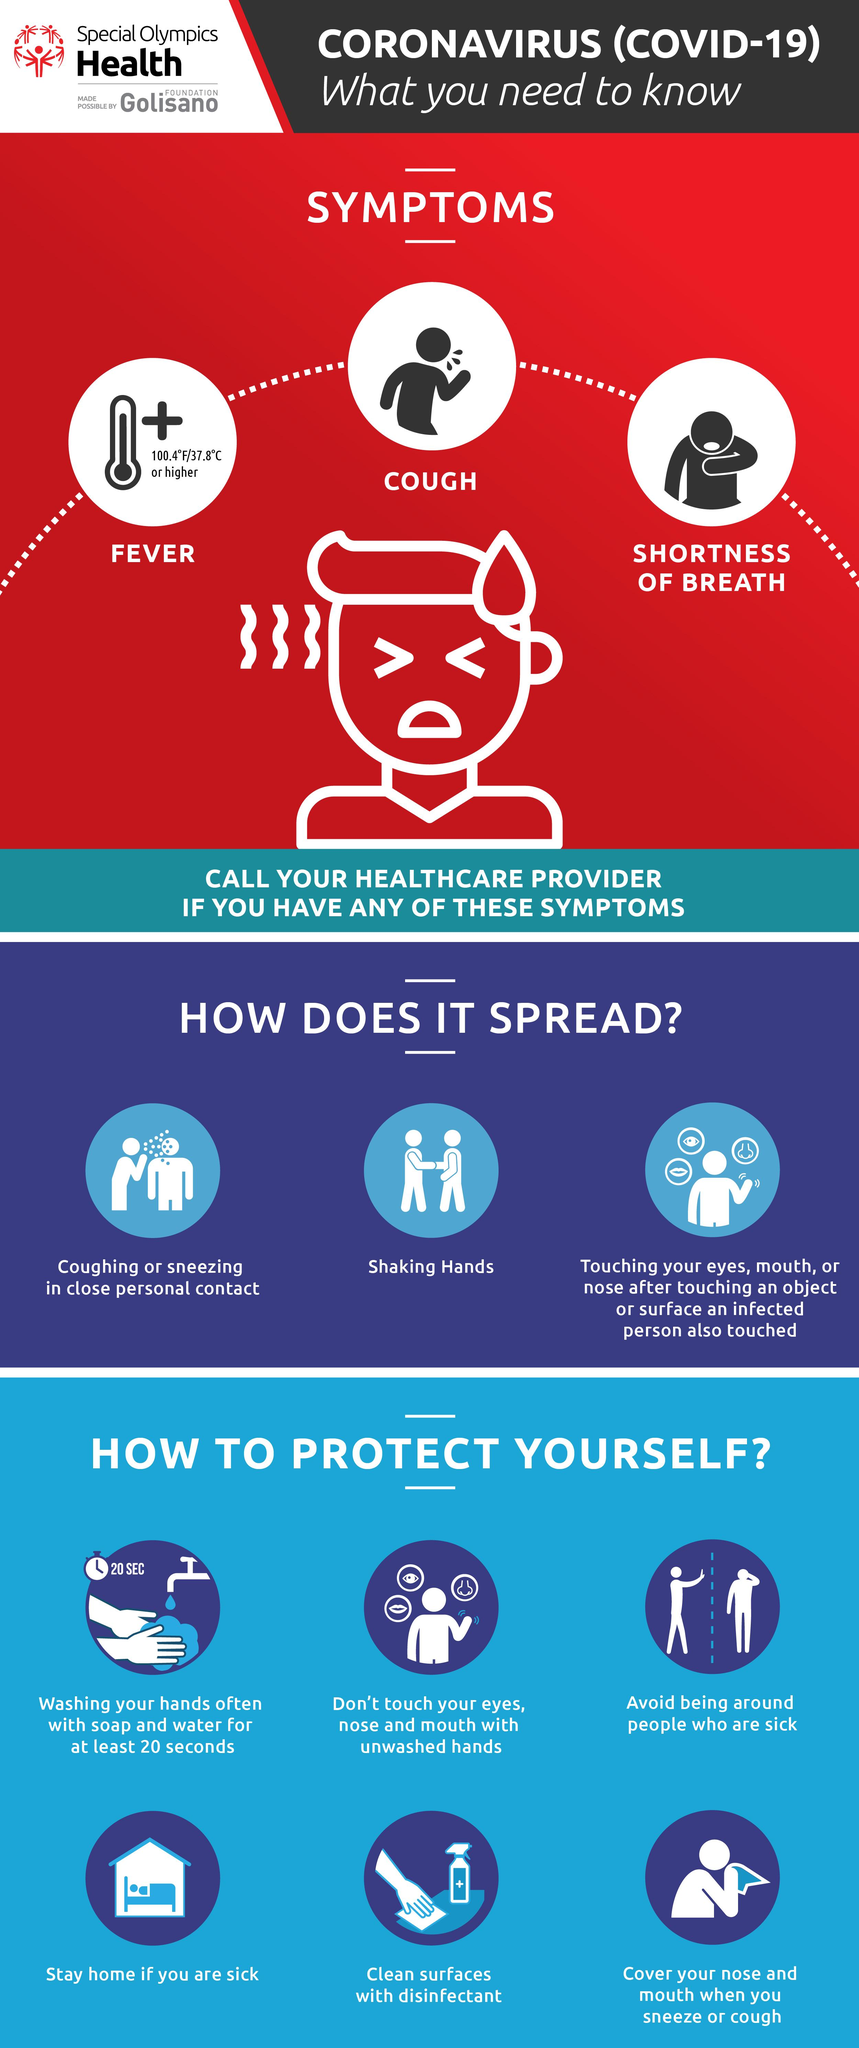Indicate a few pertinent items in this graphic. There are six ways to protect ourselves. The image contains the number 20, as indicated by a tap and a hand. The symptoms of COVID-19 are fever, cough, and shortness of breath. It is recommended to use a disinfectant to clean surfaces. The recommended duration for washing hands with soap and water is 20 seconds. 